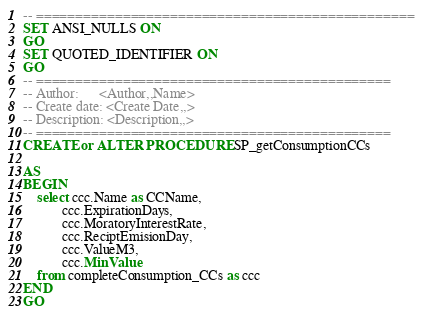Convert code to text. <code><loc_0><loc_0><loc_500><loc_500><_SQL_>-- ================================================
SET ANSI_NULLS ON
GO
SET QUOTED_IDENTIFIER ON
GO
-- =============================================
-- Author:		<Author,,Name>
-- Create date: <Create Date,,>
-- Description:	<Description,,>
-- =============================================
CREATE or ALTER PROCEDURE SP_getConsumptionCCs
	
AS
BEGIN
	select ccc.Name as CCName,
		   ccc.ExpirationDays, 
		   ccc.MoratoryInterestRate, 
		   ccc.ReciptEmisionDay, 
		   ccc.ValueM3,
		   ccc.MinValue
	from completeConsumption_CCs as ccc
END
GO
</code> 